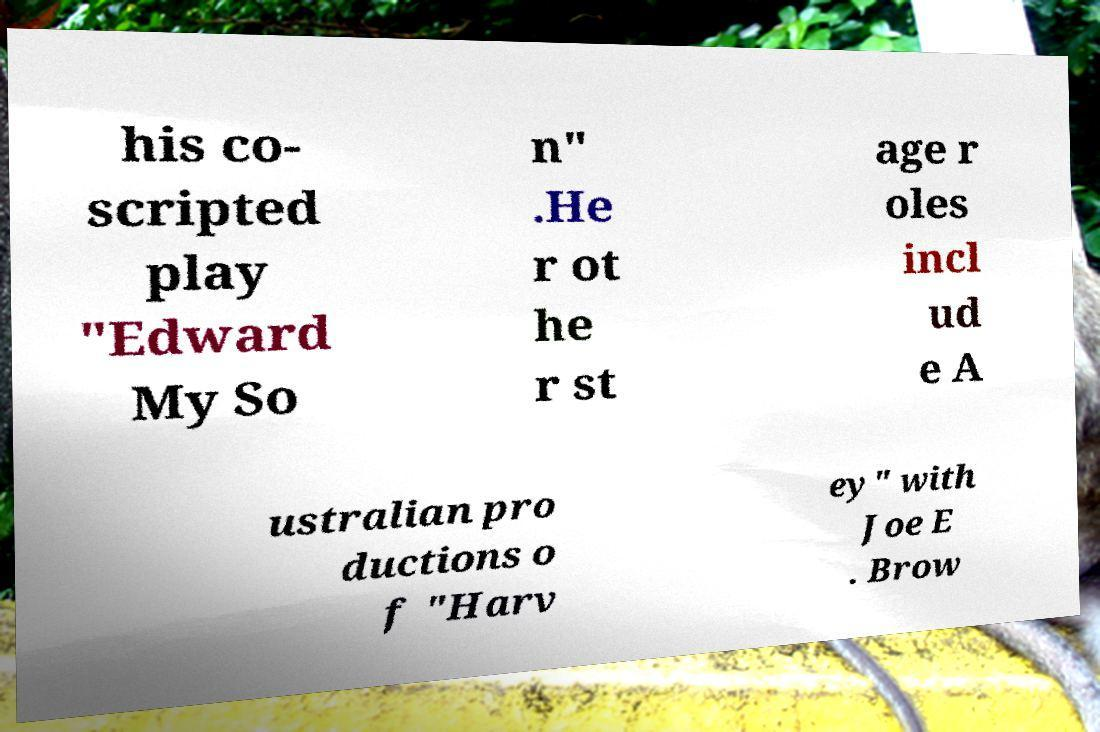Could you assist in decoding the text presented in this image and type it out clearly? his co- scripted play "Edward My So n" .He r ot he r st age r oles incl ud e A ustralian pro ductions o f "Harv ey" with Joe E . Brow 